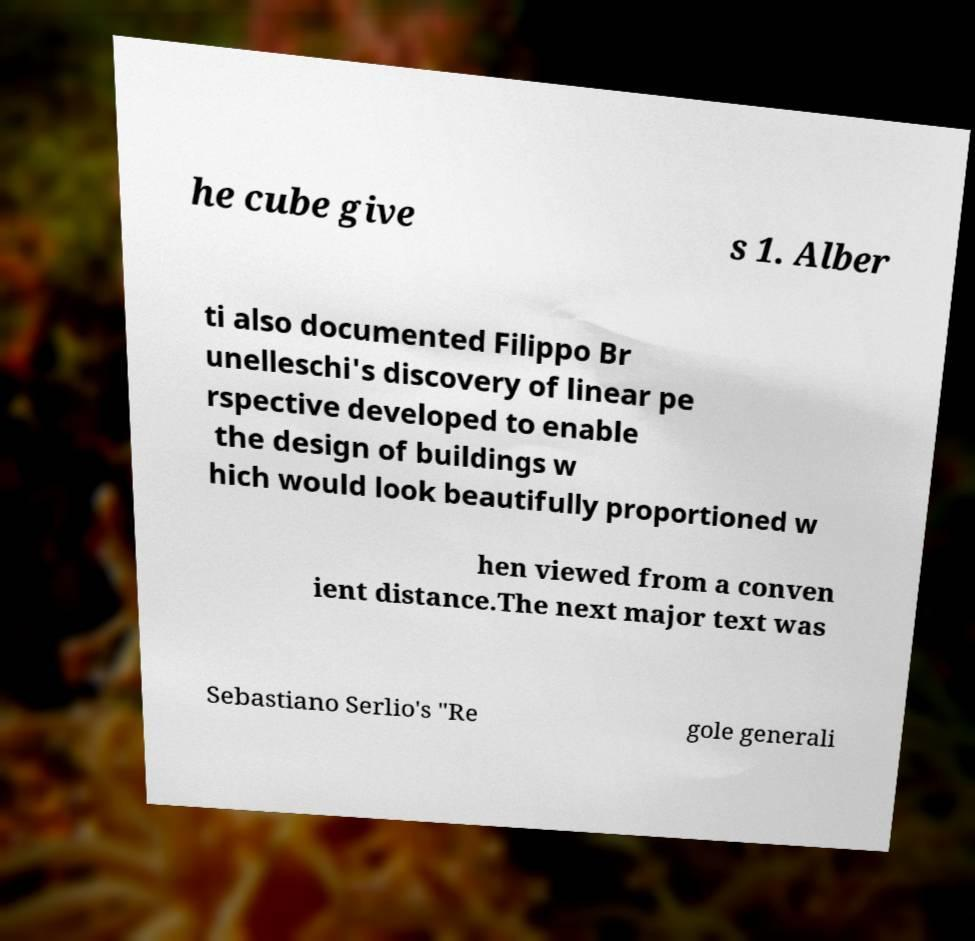I need the written content from this picture converted into text. Can you do that? he cube give s 1. Alber ti also documented Filippo Br unelleschi's discovery of linear pe rspective developed to enable the design of buildings w hich would look beautifully proportioned w hen viewed from a conven ient distance.The next major text was Sebastiano Serlio's "Re gole generali 